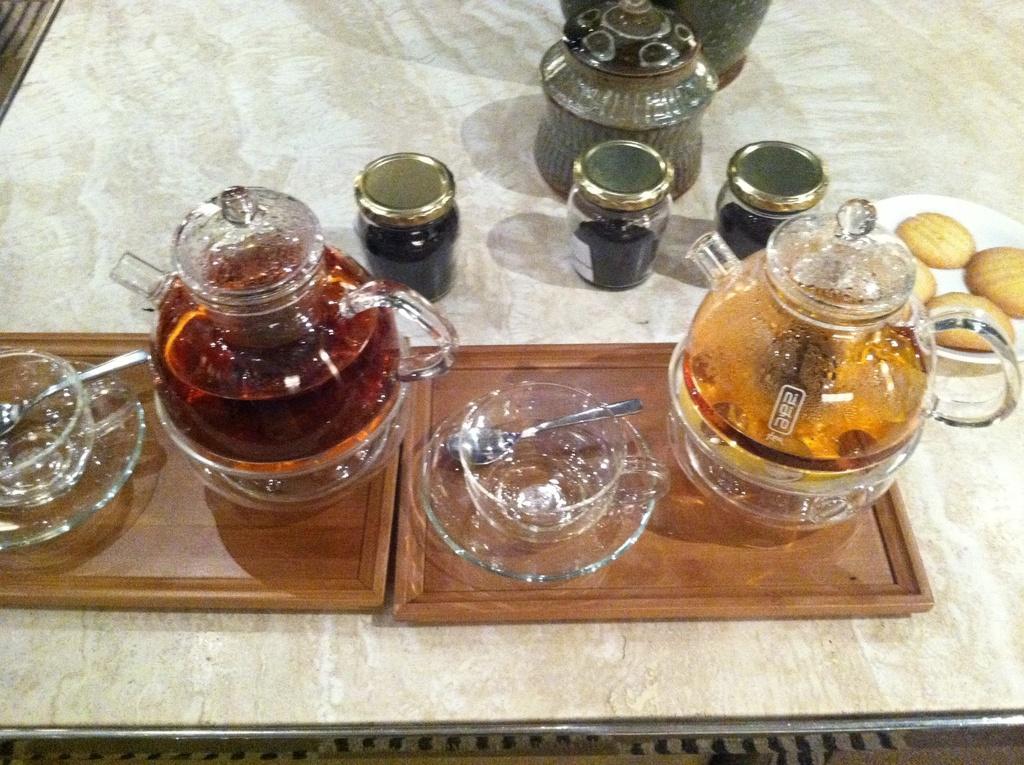Please provide a concise description of this image. In this image there is a table and we can see jars, cup, saucers, trays, plate, biscuits and a vase placed on the table. We can see jars containing honey. 